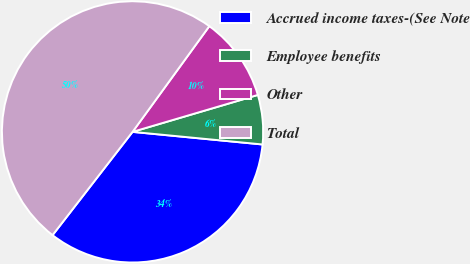<chart> <loc_0><loc_0><loc_500><loc_500><pie_chart><fcel>Accrued income taxes-(See Note<fcel>Employee benefits<fcel>Other<fcel>Total<nl><fcel>33.95%<fcel>6.1%<fcel>10.44%<fcel>49.51%<nl></chart> 